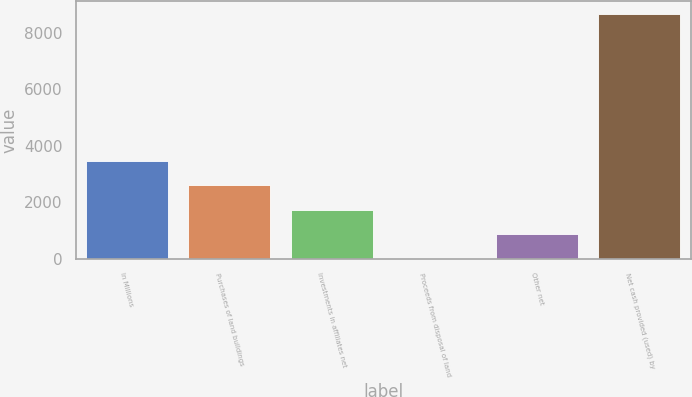Convert chart to OTSL. <chart><loc_0><loc_0><loc_500><loc_500><bar_chart><fcel>In Millions<fcel>Purchases of land buildings<fcel>Investments in affiliates net<fcel>Proceeds from disposal of land<fcel>Other net<fcel>Net cash provided (used) by<nl><fcel>3475<fcel>2606.6<fcel>1738.2<fcel>1.4<fcel>869.8<fcel>8685.4<nl></chart> 